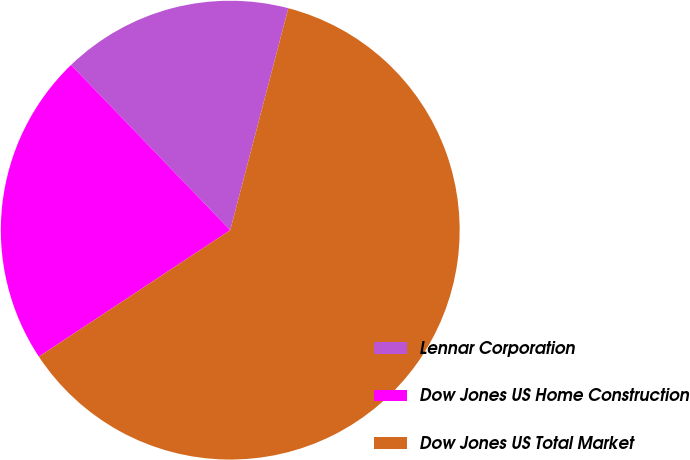Convert chart. <chart><loc_0><loc_0><loc_500><loc_500><pie_chart><fcel>Lennar Corporation<fcel>Dow Jones US Home Construction<fcel>Dow Jones US Total Market<nl><fcel>16.28%<fcel>22.09%<fcel>61.63%<nl></chart> 